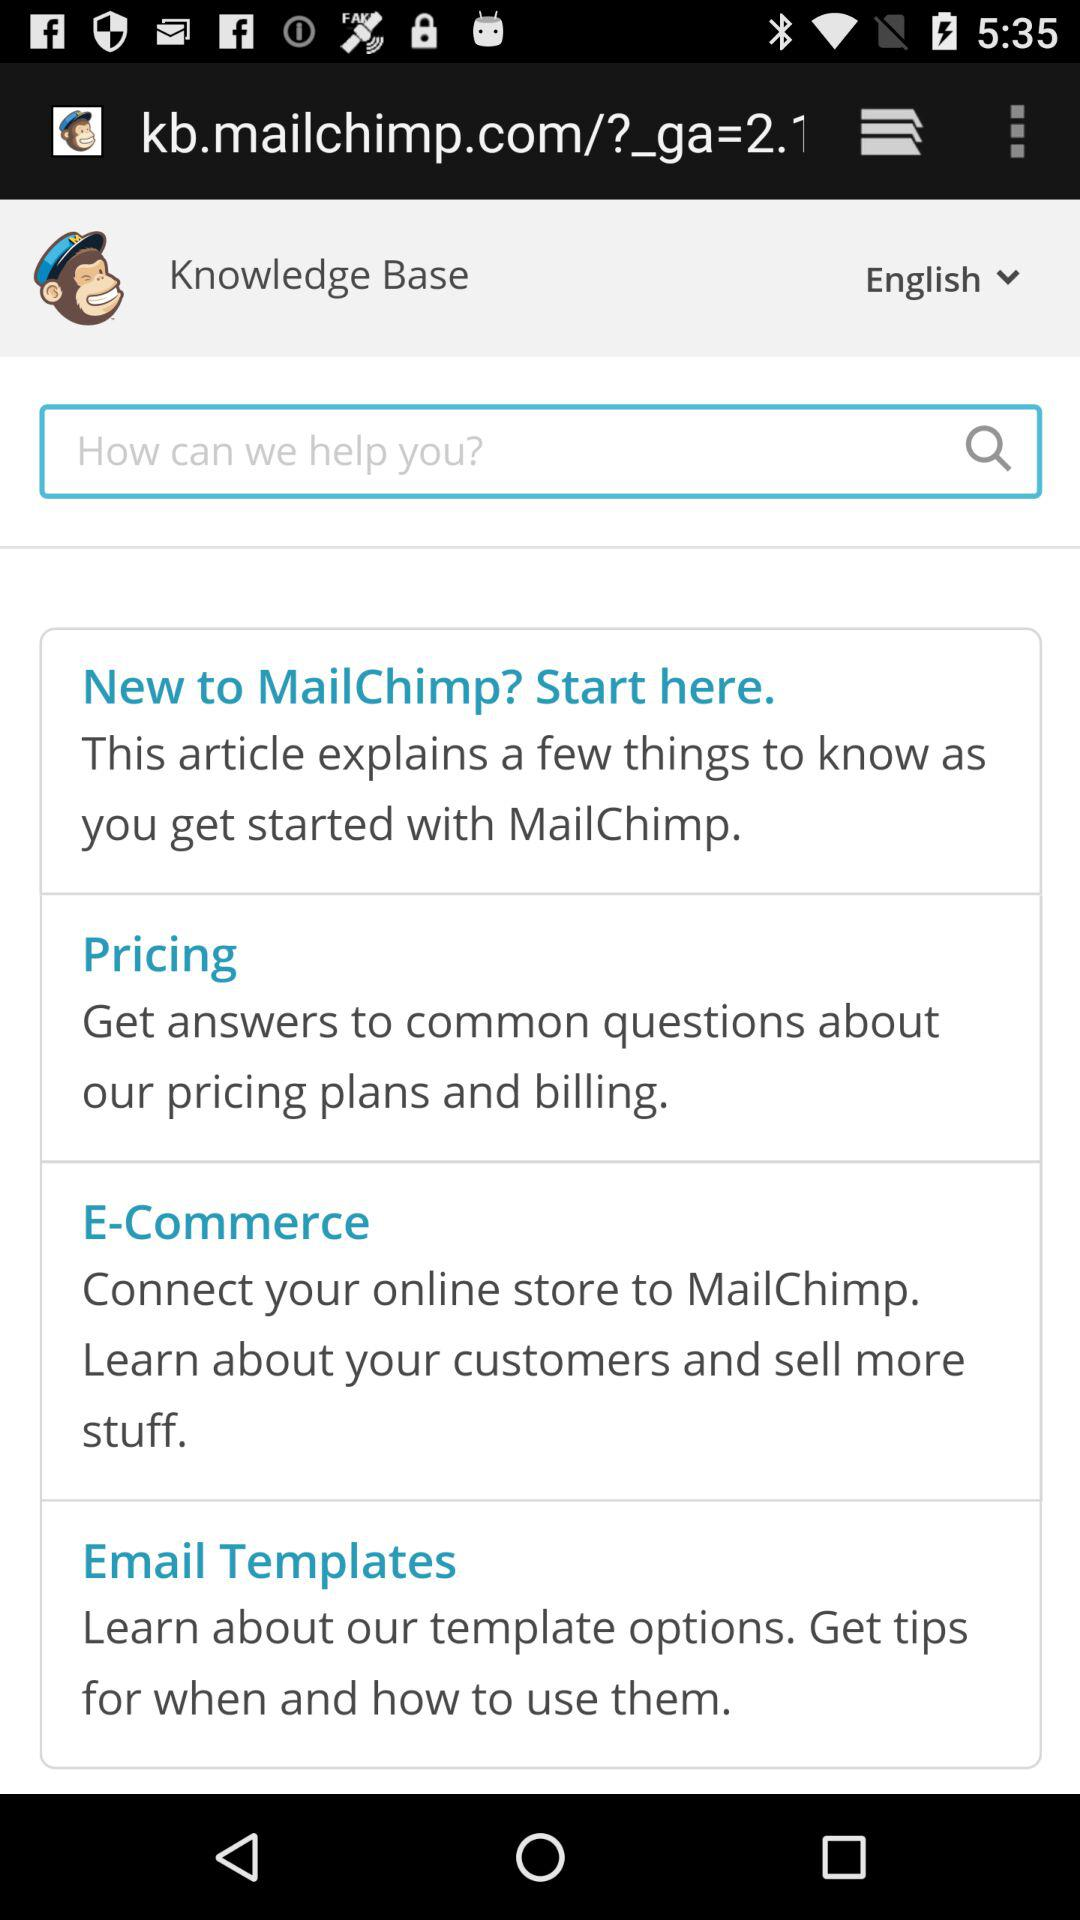What is the name of the application? The name of the application is "MailChimp". 